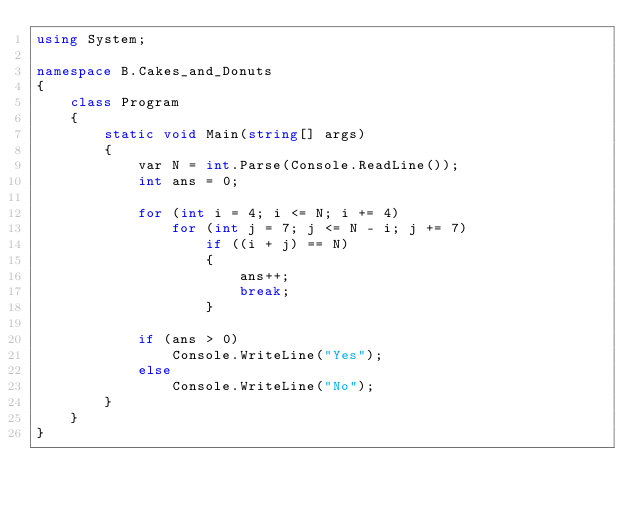<code> <loc_0><loc_0><loc_500><loc_500><_C#_>using System;

namespace B.Cakes_and_Donuts
{
    class Program
    {
        static void Main(string[] args)
        {
            var N = int.Parse(Console.ReadLine());
            int ans = 0;

            for (int i = 4; i <= N; i += 4)
                for (int j = 7; j <= N - i; j += 7)
                    if ((i + j) == N)
                    {
                        ans++;
                        break;
                    }

            if (ans > 0)
                Console.WriteLine("Yes");
            else
                Console.WriteLine("No");
        }
    }
}
</code> 